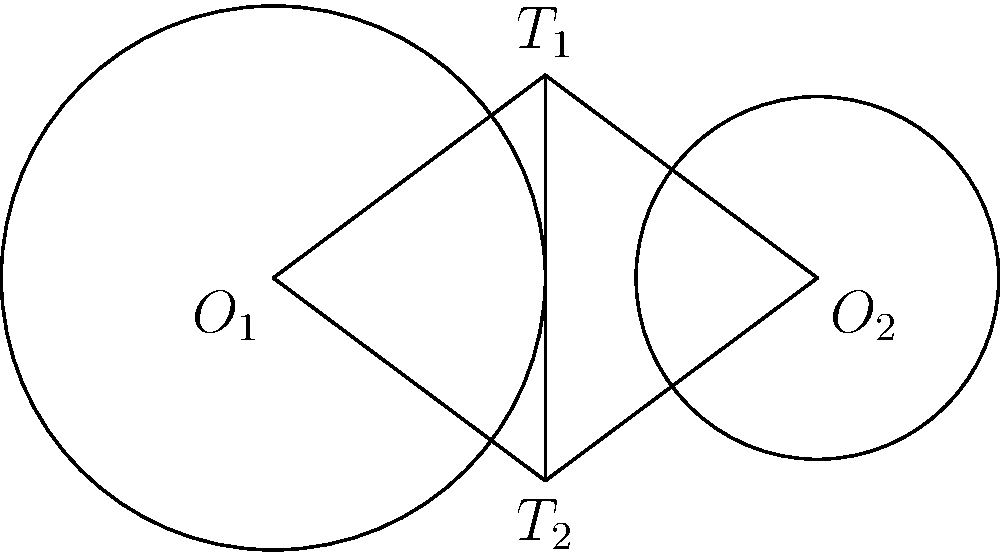During a football strategy session, you're analyzing a play diagram that resembles two intersecting circles. The centers of the circles represent two players, and the radii represent their reach. The distance between the players is 6 yards. One player has a reach of 3 yards, while the other has a reach of 2 yards. What is the length of the common tangent line between these two circles, representing the optimal passing route? Let's approach this step-by-step:

1) Let the centers of the circles be $O_1$ and $O_2$, with radii $r_1 = 3$ and $r_2 = 2$ respectively.

2) The distance between the centers is $d = 6$.

3) Let's call the points where the common tangent touches the circles $T_1$ and $T_2$.

4) The line $O_1T_1$ is perpendicular to the tangent, as is $O_2T_2$.

5) Therefore, triangles $O_1T_1O_2$ and $O_2T_2O_1$ are right-angled triangles.

6) In the right-angled triangle $O_1T_1O_2$:
   
   $O_1O_2^2 = O_1T_1^2 + O_2T_1^2$
   
   $6^2 = 3^2 + O_2T_1^2$
   
   $36 = 9 + O_2T_1^2$
   
   $O_2T_1^2 = 27$

7) The length of the tangent, $T_1T_2$, is equal to $O_2T_1$.

8) Therefore, $T_1T_2 = \sqrt{27} = 3\sqrt{3}$ yards.

This length represents the optimal passing route between the two players' reach areas.
Answer: $3\sqrt{3}$ yards 